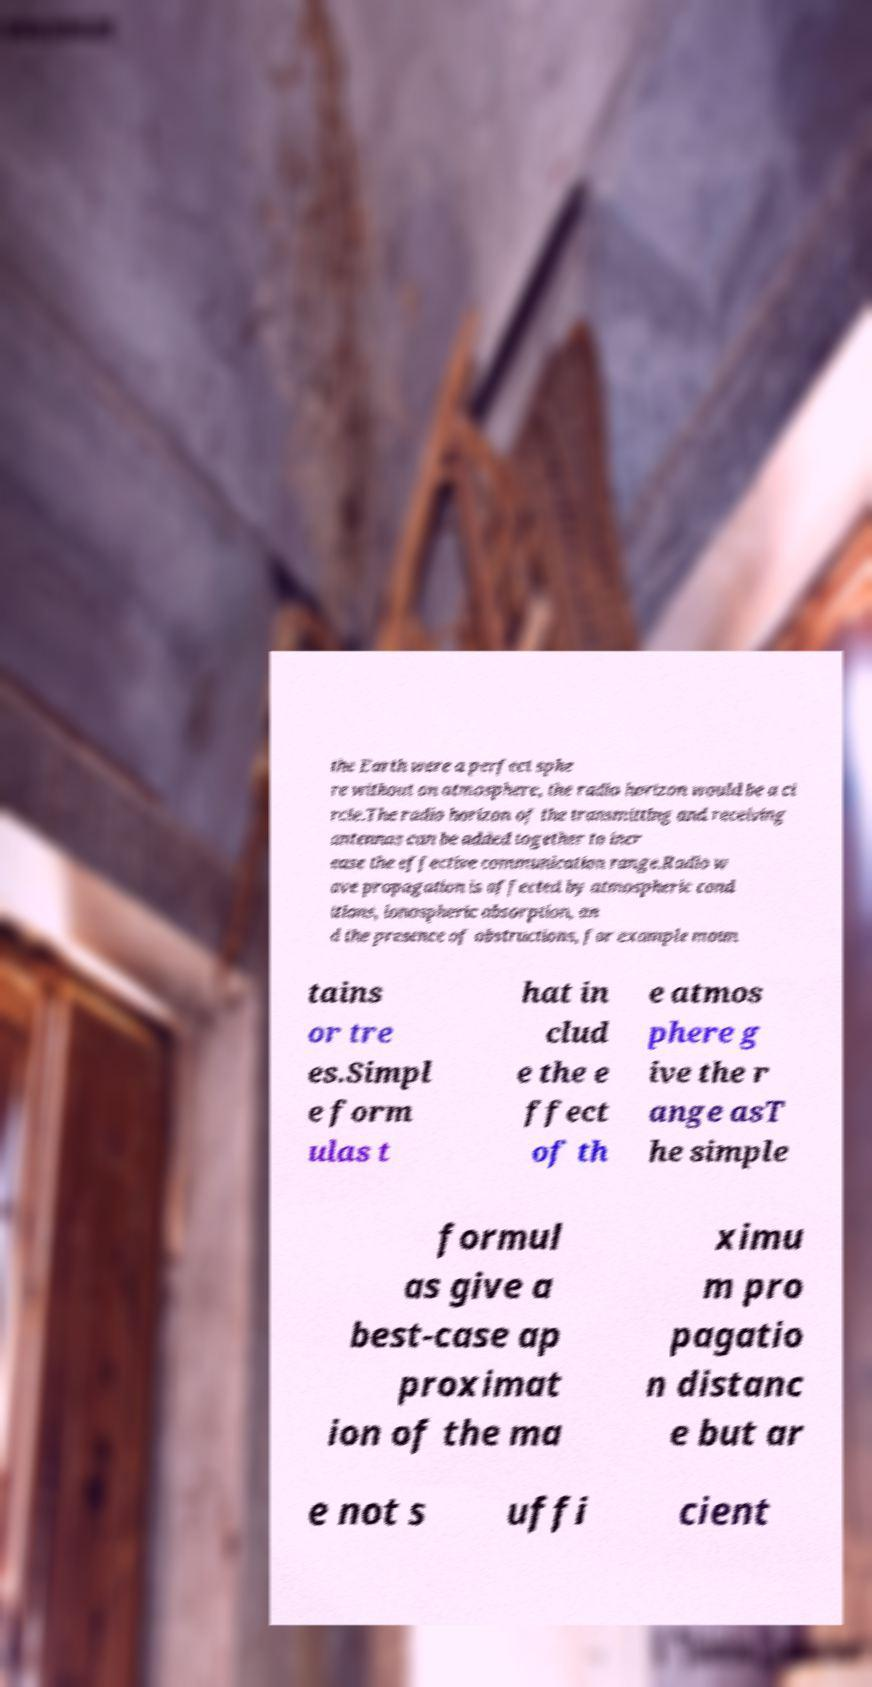Can you accurately transcribe the text from the provided image for me? the Earth were a perfect sphe re without an atmosphere, the radio horizon would be a ci rcle.The radio horizon of the transmitting and receiving antennas can be added together to incr ease the effective communication range.Radio w ave propagation is affected by atmospheric cond itions, ionospheric absorption, an d the presence of obstructions, for example moun tains or tre es.Simpl e form ulas t hat in clud e the e ffect of th e atmos phere g ive the r ange asT he simple formul as give a best-case ap proximat ion of the ma ximu m pro pagatio n distanc e but ar e not s uffi cient 